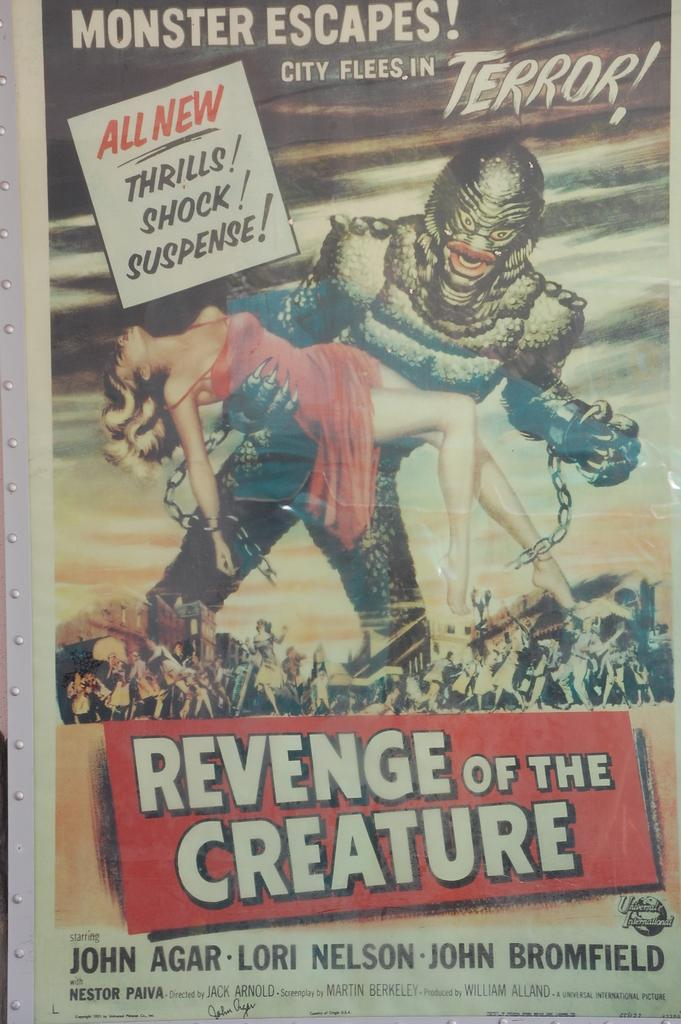<image>
Offer a succinct explanation of the picture presented. A horror comic titled Revenge of the Creature. 